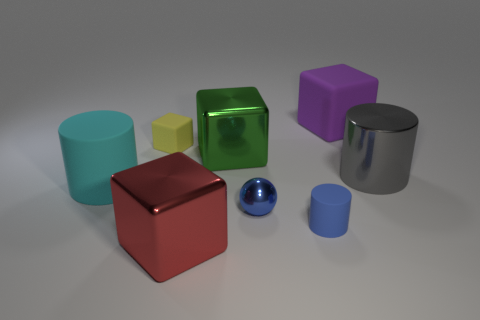Is there a small ball of the same color as the small rubber cylinder?
Your answer should be compact. Yes. What color is the shiny cylinder that is the same size as the purple block?
Your answer should be compact. Gray. There is a large shiny thing to the right of the small matte cylinder that is right of the small thing that is behind the gray cylinder; what shape is it?
Your answer should be very brief. Cylinder. What number of tiny matte things are in front of the tiny matte thing to the left of the tiny blue metallic object?
Your answer should be compact. 1. There is a large matte thing left of the large red cube; does it have the same shape as the small blue rubber thing in front of the big cyan thing?
Provide a succinct answer. Yes. What number of big green shiny cubes are to the left of the big matte block?
Offer a terse response. 1. Are the big cylinder behind the cyan rubber cylinder and the red cube made of the same material?
Provide a short and direct response. Yes. There is another big shiny thing that is the same shape as the large green shiny object; what is its color?
Give a very brief answer. Red. What shape is the green object?
Your response must be concise. Cube. What number of things are tiny blue cylinders or small blue metal balls?
Keep it short and to the point. 2. 